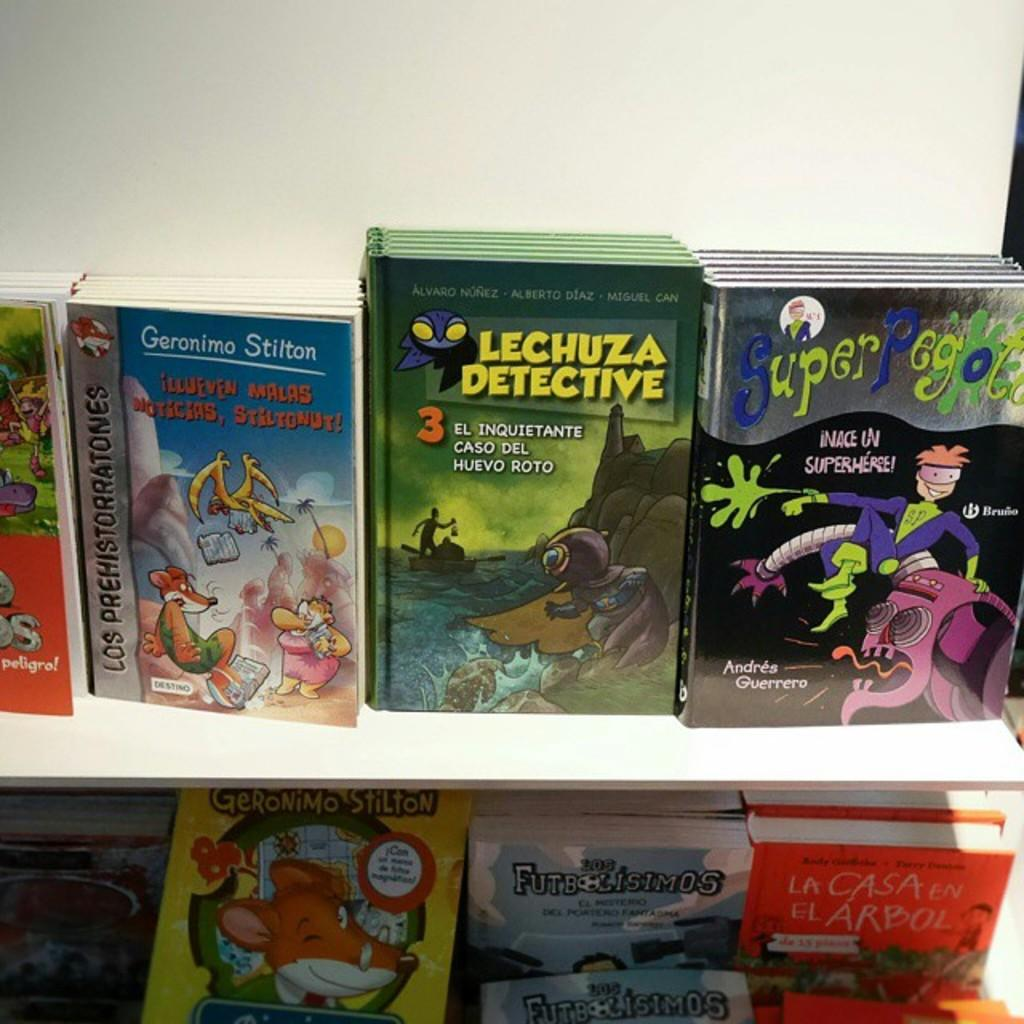<image>
Present a compact description of the photo's key features. The book to the right on the second shelf is titled, "La Casa en el Arbol." 